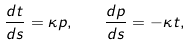<formula> <loc_0><loc_0><loc_500><loc_500>\frac { d { t } } { d s } = \kappa { p } , \quad \frac { d { p } } { d s } = - \kappa { t } ,</formula> 